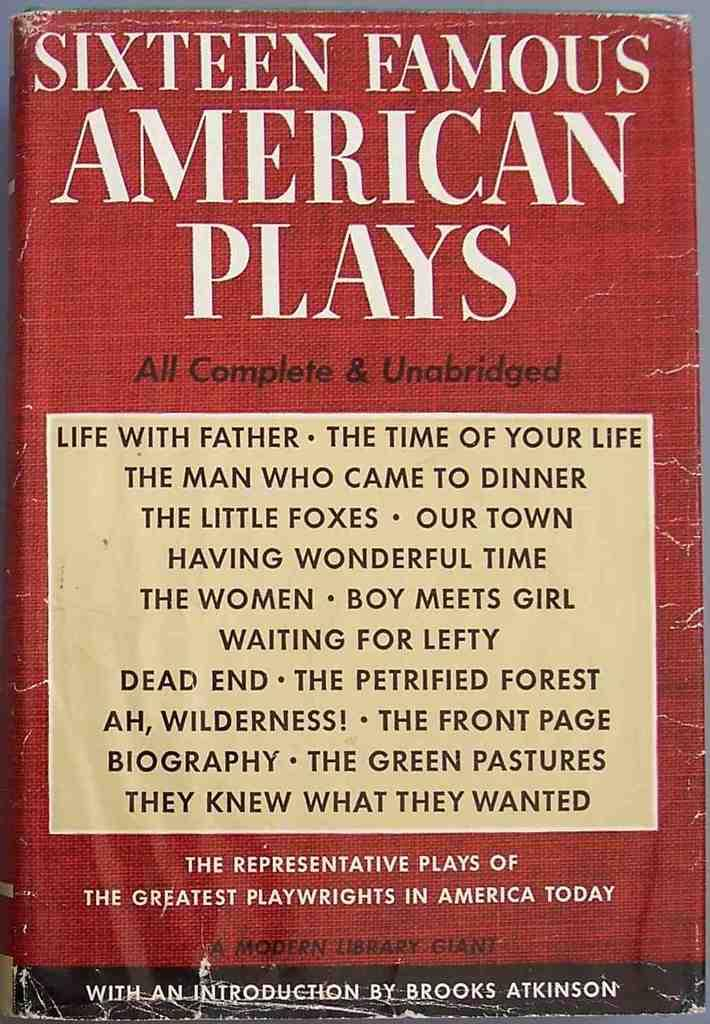<image>
Relay a brief, clear account of the picture shown. Sixteen Famous American Plays are compiled into a book. 